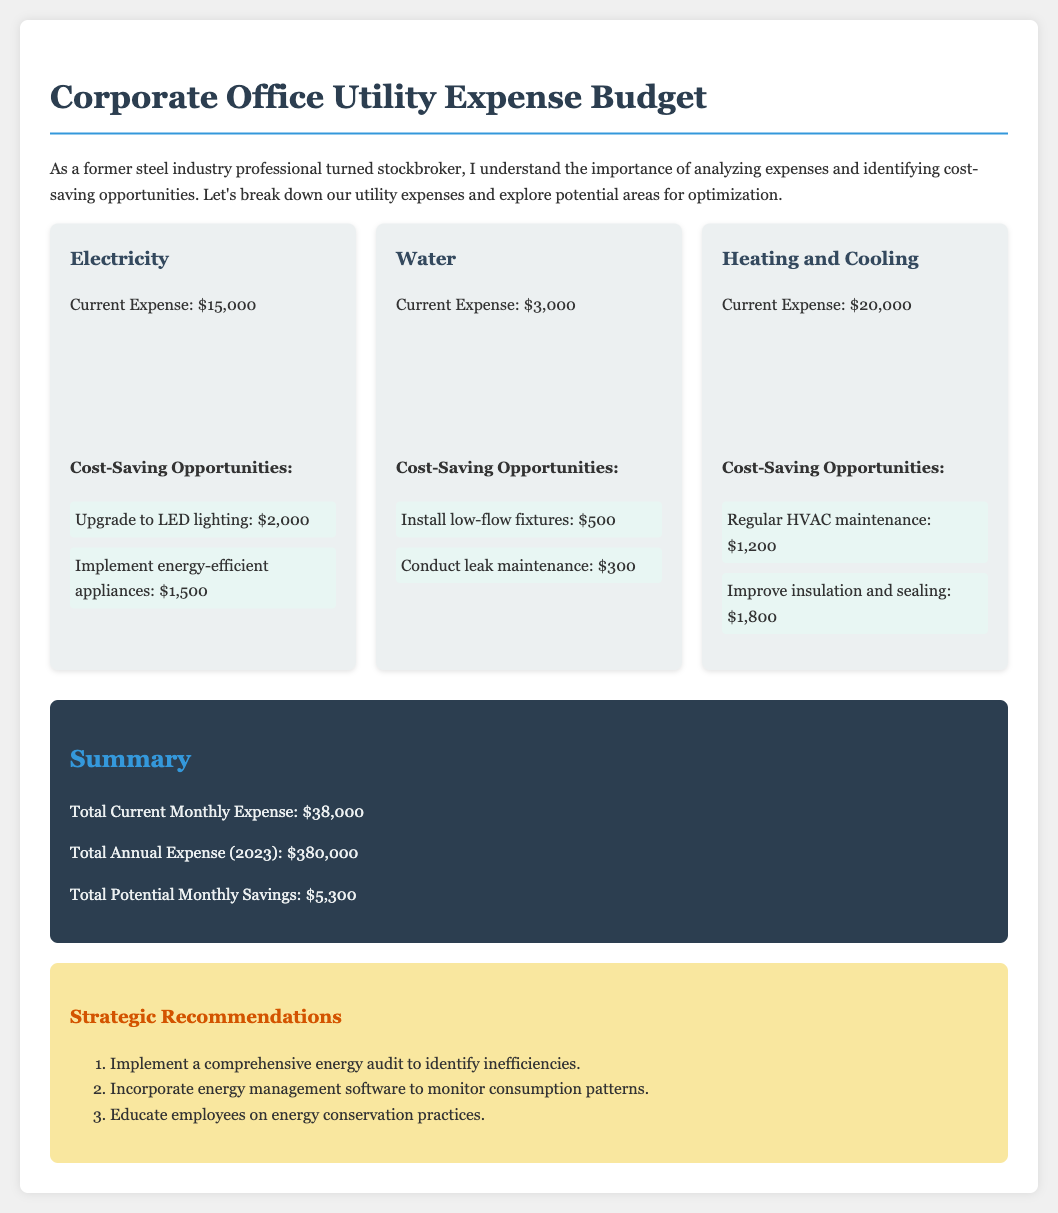what is the current expense for electricity? The current expense for electricity is clearly stated in the document.
Answer: $15,000 what are the cost-saving opportunities for water? The document lists specific cost-saving opportunities associated with the water utility expense.
Answer: Install low-flow fixtures: $500, Conduct leak maintenance: $300 what is the total potential monthly savings? The total potential monthly savings is directly provided in the summary section of the document.
Answer: $5,300 what percentage increase does the cost of heating and cooling show from 2021 to 2023? By analyzing the yearly expenses for heating and cooling from 2021 to 2023, we can determine the percentage increase.
Answer: 11.11% how much was spent on water in 2022? The document provides specific expense amounts for each year, including water expenses for 2022.
Answer: $28,000 what is the current expense for heating and cooling? The current expense for heating and cooling can be found in the dedicated section for that item in the document.
Answer: $20,000 name one strategic recommendation mentioned. The recommendations section suggests various strategies, any of which could be potential answers.
Answer: Implement a comprehensive energy audit to identify inefficiencies how much did the electricity expense increase from 2022 to 2023? The document provides the numbers for the electricity expenses in both years, allowing for calculation of the increase.
Answer: $20,000 what is the total annual expense for 2023? The total annual expense for 2023 is summarized clearly in the document.
Answer: $380,000 